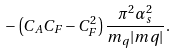Convert formula to latex. <formula><loc_0><loc_0><loc_500><loc_500>- \left ( C _ { A } C _ { F } - C _ { F } ^ { 2 } \right ) \frac { \pi ^ { 2 } \alpha _ { s } ^ { 2 } } { m _ { q } | { m q } | } .</formula> 